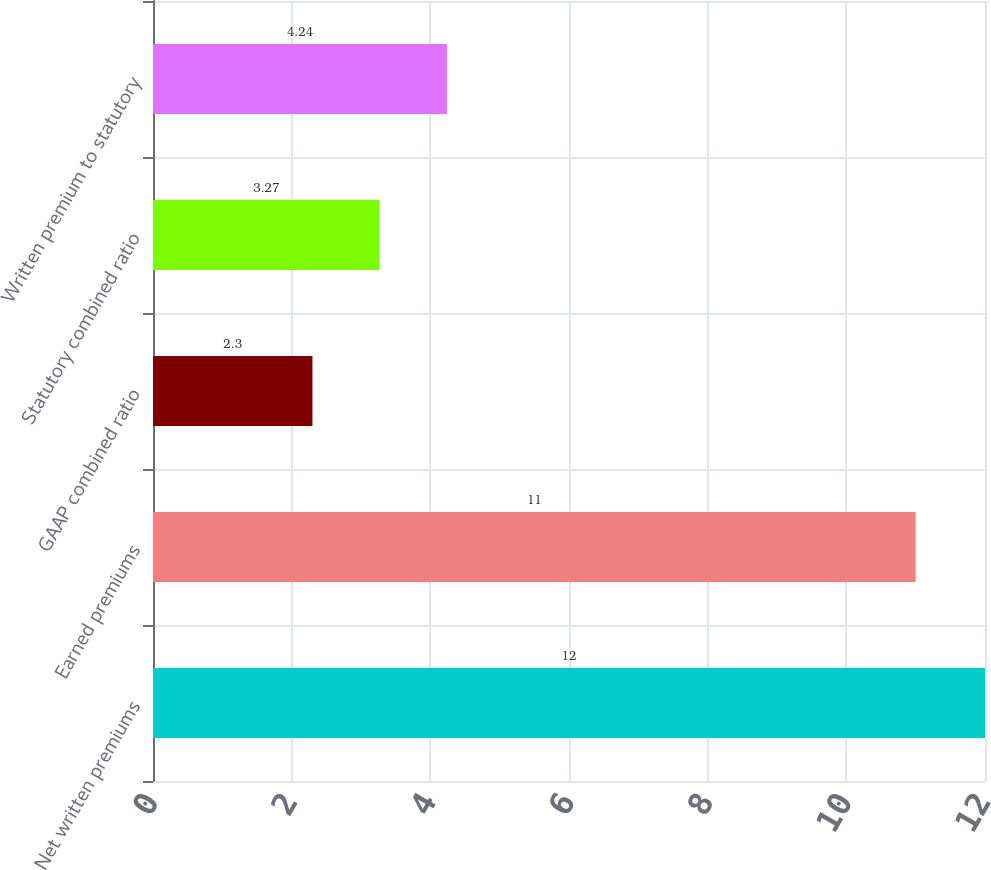Convert chart to OTSL. <chart><loc_0><loc_0><loc_500><loc_500><bar_chart><fcel>Net written premiums<fcel>Earned premiums<fcel>GAAP combined ratio<fcel>Statutory combined ratio<fcel>Written premium to statutory<nl><fcel>12<fcel>11<fcel>2.3<fcel>3.27<fcel>4.24<nl></chart> 